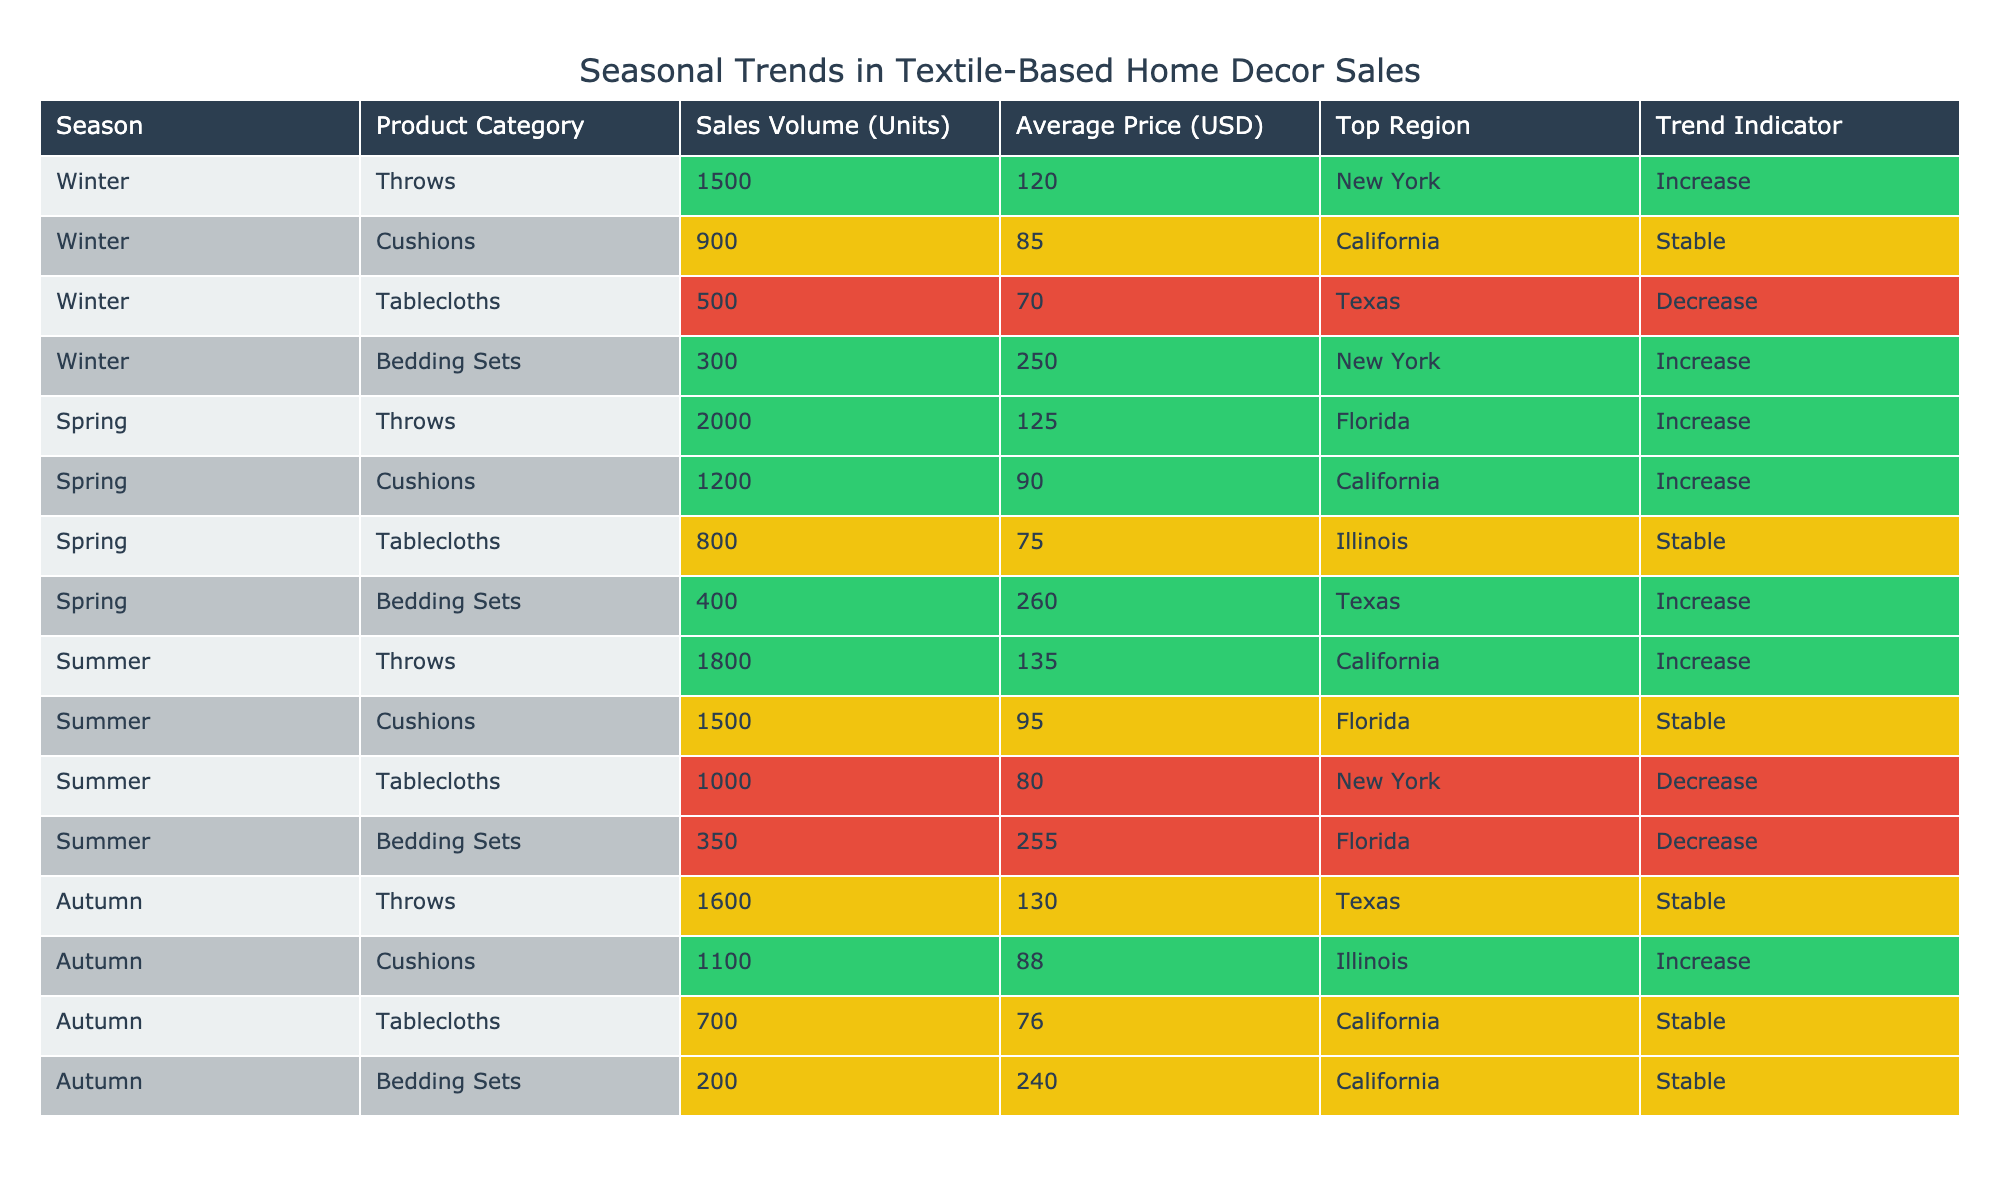What is the top region for Throws in Spring? In the Spring season, the product category Throws lists Florida as the top region. I can find this by looking under the Spring row for the Throws category in the table.
Answer: Florida How many units of Cushions were sold in Winter? The sales volume for Cushions in the Winter season is listed as 900 units in the corresponding row of the table.
Answer: 900 What is the average price of Tablecloths across all seasons? The average prices of Tablecloths in different seasons are: Winter (70), Spring (75), Summer (80), and Autumn (76). Summing these gives 70 + 75 + 80 + 76 = 301. There are 4 seasons, so the average price is 301/4 = 75.25.
Answer: 75.25 Is there an increase in sales volume for Bedding Sets from Winter to Spring? In Winter, the sales volume for Bedding Sets is 300 units, and in Spring, it is 400 units. Since 400 is greater than 300, it indicates an increase in sales volume.
Answer: Yes What is the trend indicator for Cushions in Autumn? Looking at the Autumn row in the Cushions category, the trend indicator is listed as Increase.
Answer: Increase How many units of Throws were sold in Summer compared to Winter? In Winter, Throws sold 1500 units, while in Summer, they sold 1800 units. To find the difference, I subtract Winter's sales from Summer's: 1800 - 1500 = 300 additional units sold in Summer.
Answer: 300 Which season has the highest sales volume for Bedding Sets, and what is that volume? The sales volumes for Bedding Sets are: Winter (300), Spring (400), Summer (350), and Autumn (200). The highest sales volume is in Spring with 400 units.
Answer: Spring, 400 Was there any season where Tablecloths saw a stable trend? Yes, when reviewing the trend indicators for Tablecloths, both Spring and Autumn are marked as Stable.
Answer: Yes What is the total sales volume for Throws across all seasons? Adding the sales volumes for Throws: Winter (1500), Spring (2000), Summer (1800), and Autumn (1600) gives a total of 1500 + 2000 + 1800 + 1600 = 6900 units sold across all seasons.
Answer: 6900 Which product category had a stable trend indicator in both Winter and Autumn? Upon reviewing the table, Cushions in Winter have a stable trend, and Tablecloths in Autumn also have a stable trend indicated. However, focusing on one product, the only category showing stable in both seasons is Tablecloths.
Answer: Tablecloths 